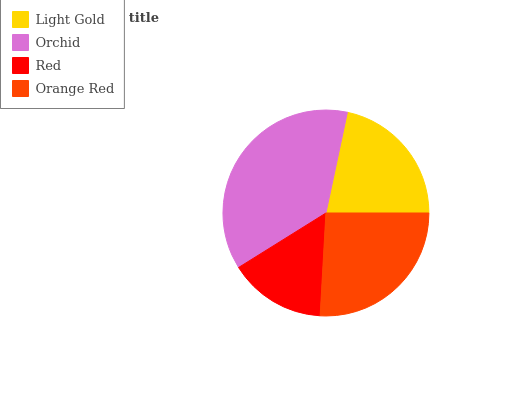Is Red the minimum?
Answer yes or no. Yes. Is Orchid the maximum?
Answer yes or no. Yes. Is Orchid the minimum?
Answer yes or no. No. Is Red the maximum?
Answer yes or no. No. Is Orchid greater than Red?
Answer yes or no. Yes. Is Red less than Orchid?
Answer yes or no. Yes. Is Red greater than Orchid?
Answer yes or no. No. Is Orchid less than Red?
Answer yes or no. No. Is Orange Red the high median?
Answer yes or no. Yes. Is Light Gold the low median?
Answer yes or no. Yes. Is Red the high median?
Answer yes or no. No. Is Orchid the low median?
Answer yes or no. No. 